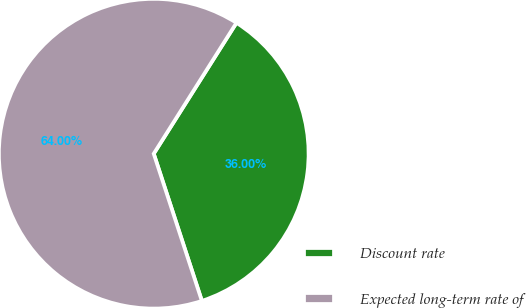Convert chart. <chart><loc_0><loc_0><loc_500><loc_500><pie_chart><fcel>Discount rate<fcel>Expected long-term rate of<nl><fcel>36.0%<fcel>64.0%<nl></chart> 